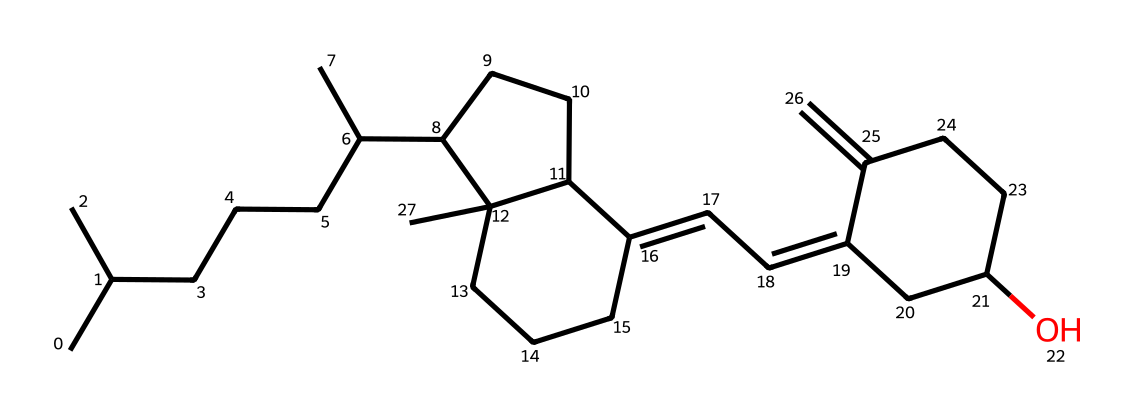What is the name of this chemical? This structure represents vitamin D, which is a fat-soluble vitamin synthesized in the skin upon exposure to UV light.
Answer: vitamin D How many carbon atoms are present in this structure? To determine the number of carbon atoms, count all the carbon atoms represented in the chemical structure. The SMILES notation reveals a total of 27 carbon atoms.
Answer: 27 What is the primary functional group present in this chemical? Analyzing the structure, the hydroxyl group (-OH) present indicates the presence of an alcohol functional group, which is significant in characterizing vitamin D.
Answer: alcohol Does this compound contain rings in its structure? A close inspection of the structure shows there are multiple cyclic structures, indicating it does contain rings. Counting reveals at least two distinct rings in the chemical.
Answer: yes What type of isomerism is exhibited by this vitamin D structure? The presence of multiple stereocenters in the structure suggests that this compound can exist as different stereoisomers, specifically geometric isomerism because of double bonds and configurations around rings.
Answer: stereoisomerism Is vitamin D water-soluble or fat-soluble? Given its structural features, particularly the long hydrocarbon chains and rings, it indicates that vitamin D is indeed soluble in fats rather than in water.
Answer: fat-soluble 